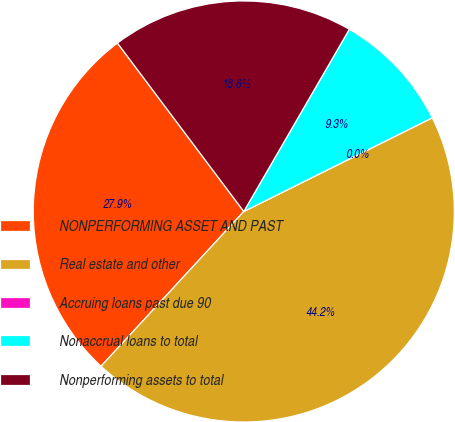Convert chart to OTSL. <chart><loc_0><loc_0><loc_500><loc_500><pie_chart><fcel>NONPERFORMING ASSET AND PAST<fcel>Real estate and other<fcel>Accruing loans past due 90<fcel>Nonaccrual loans to total<fcel>Nonperforming assets to total<nl><fcel>27.9%<fcel>44.2%<fcel>0.0%<fcel>9.3%<fcel>18.6%<nl></chart> 